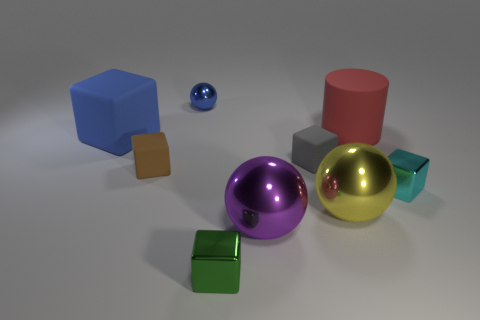How many other objects are the same color as the big matte block?
Your answer should be compact. 1. Is the number of tiny blue shiny balls that are to the left of the cyan metallic cube greater than the number of tiny yellow metallic cubes?
Give a very brief answer. Yes. The ball in front of the large yellow object that is in front of the metallic ball on the left side of the big purple sphere is what color?
Offer a very short reply. Purple. Does the red thing have the same material as the green cube?
Make the answer very short. No. Are there any brown spheres that have the same size as the gray matte block?
Offer a very short reply. No. There is a brown cube that is the same size as the gray cube; what is its material?
Your answer should be very brief. Rubber. Are there any big blue objects of the same shape as the cyan thing?
Ensure brevity in your answer.  Yes. What is the material of the object that is the same color as the tiny shiny sphere?
Your answer should be compact. Rubber. What shape is the tiny rubber thing that is to the right of the tiny green cube?
Give a very brief answer. Cube. What number of tiny yellow metal spheres are there?
Offer a very short reply. 0. 